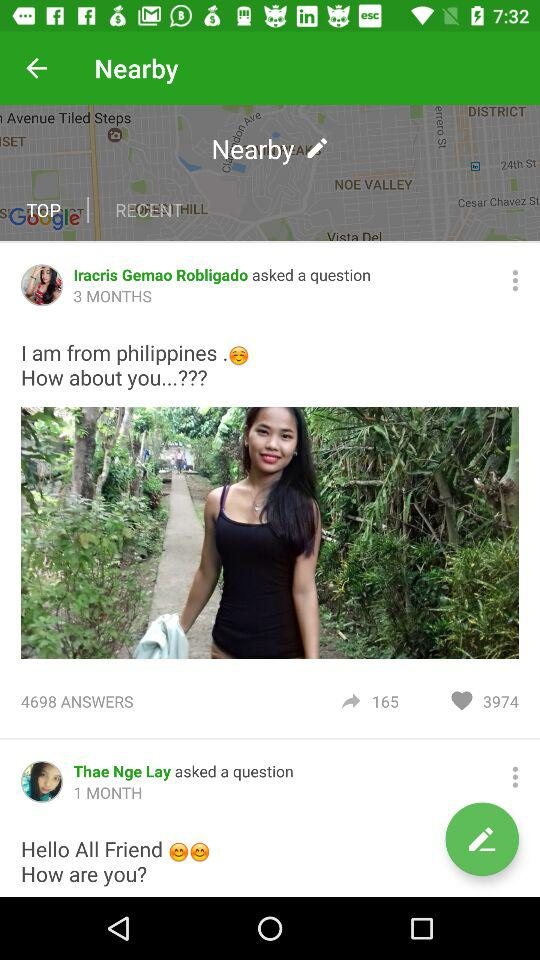How many total answers are there for Iracris Germao Robligado? There are 4698 answers for Iracris Germao Robligado. 